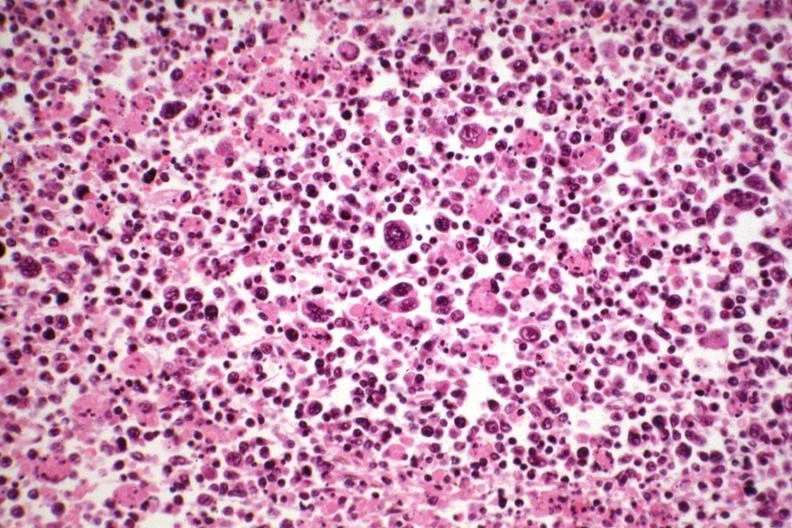what is present?
Answer the question using a single word or phrase. Lymph node 